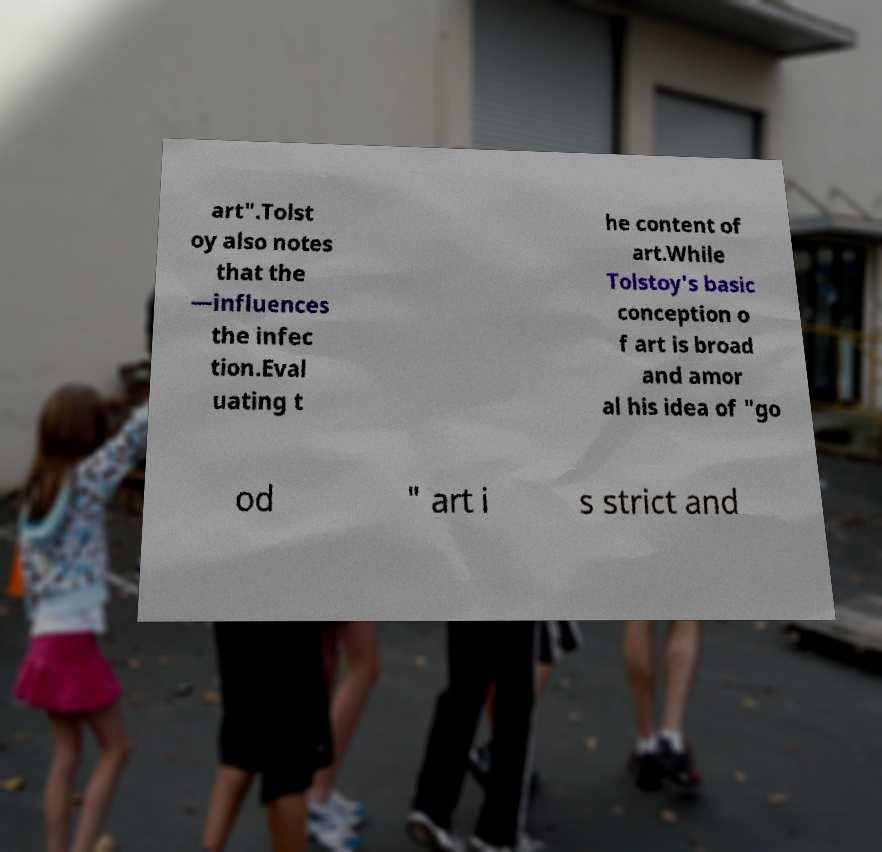What messages or text are displayed in this image? I need them in a readable, typed format. art".Tolst oy also notes that the —influences the infec tion.Eval uating t he content of art.While Tolstoy's basic conception o f art is broad and amor al his idea of "go od " art i s strict and 